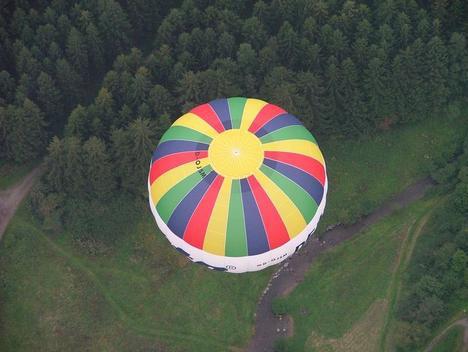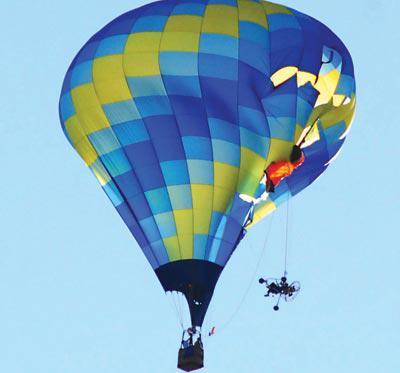The first image is the image on the left, the second image is the image on the right. Considering the images on both sides, is "There is a skydiver in the image on the right." valid? Answer yes or no. No. 